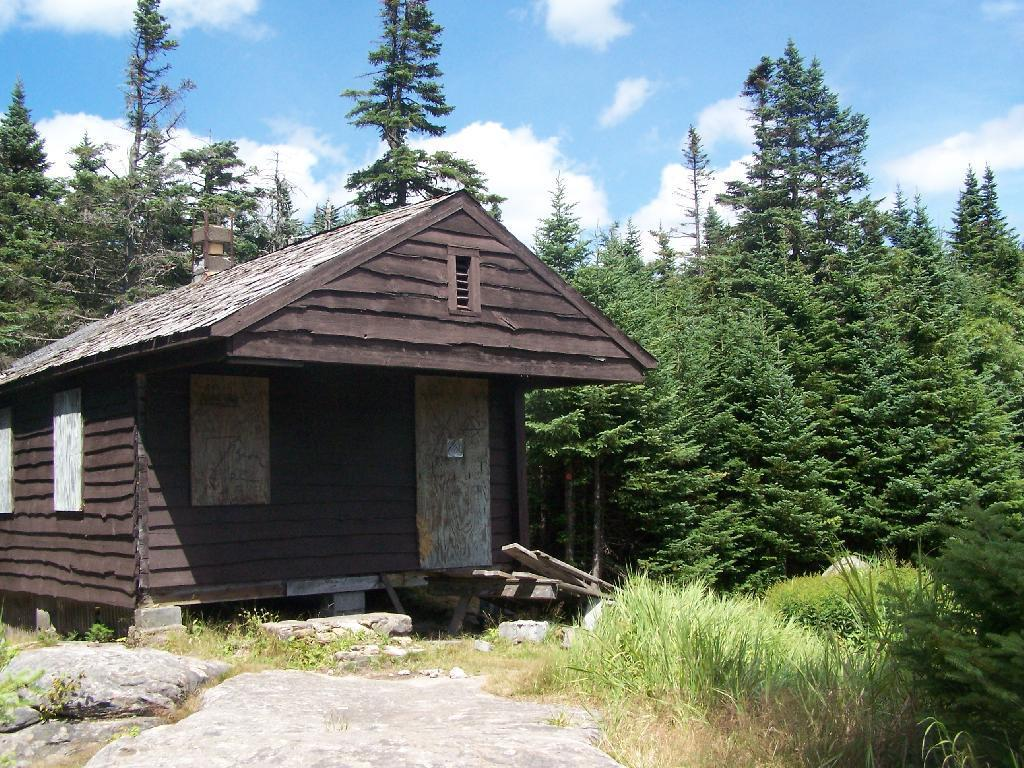What type of structure is in the image? There is a small house in the image. What can be seen in the background of the image? There are many trees in the image. What type of vegetation is present in the image? There is grass in the image. What is located in front of the house? There are stones in front of the house. What is visible at the top of the image? The sky is visible at the top of the image. How many bedrooms are there in the house in the image? The provided facts do not mention the number of bedrooms in the house, so we cannot determine that information from the image. 